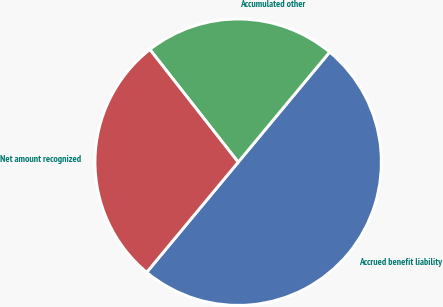Convert chart. <chart><loc_0><loc_0><loc_500><loc_500><pie_chart><fcel>Accrued benefit liability<fcel>Accumulated other<fcel>Net amount recognized<nl><fcel>50.0%<fcel>21.61%<fcel>28.39%<nl></chart> 